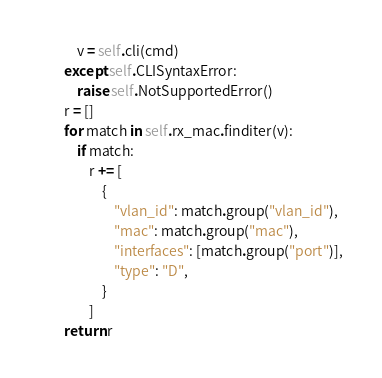Convert code to text. <code><loc_0><loc_0><loc_500><loc_500><_Python_>            v = self.cli(cmd)
        except self.CLISyntaxError:
            raise self.NotSupportedError()
        r = []
        for match in self.rx_mac.finditer(v):
            if match:
                r += [
                    {
                        "vlan_id": match.group("vlan_id"),
                        "mac": match.group("mac"),
                        "interfaces": [match.group("port")],
                        "type": "D",
                    }
                ]
        return r
</code> 